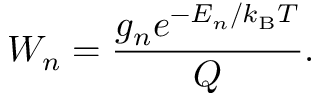Convert formula to latex. <formula><loc_0><loc_0><loc_500><loc_500>W _ { n } = \frac { g _ { n } e ^ { - E _ { n } / k _ { B } T } } { Q } .</formula> 